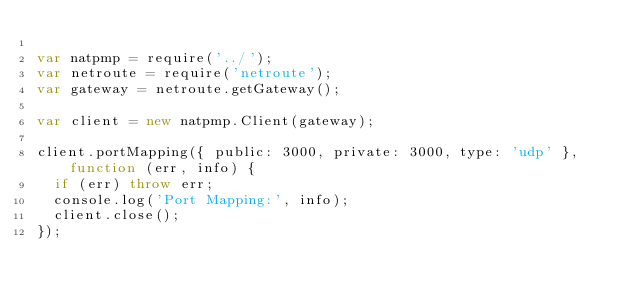<code> <loc_0><loc_0><loc_500><loc_500><_JavaScript_>
var natpmp = require('../');
var netroute = require('netroute');
var gateway = netroute.getGateway();

var client = new natpmp.Client(gateway);

client.portMapping({ public: 3000, private: 3000, type: 'udp' }, function (err, info) {
  if (err) throw err;
  console.log('Port Mapping:', info);
  client.close();
});
</code> 